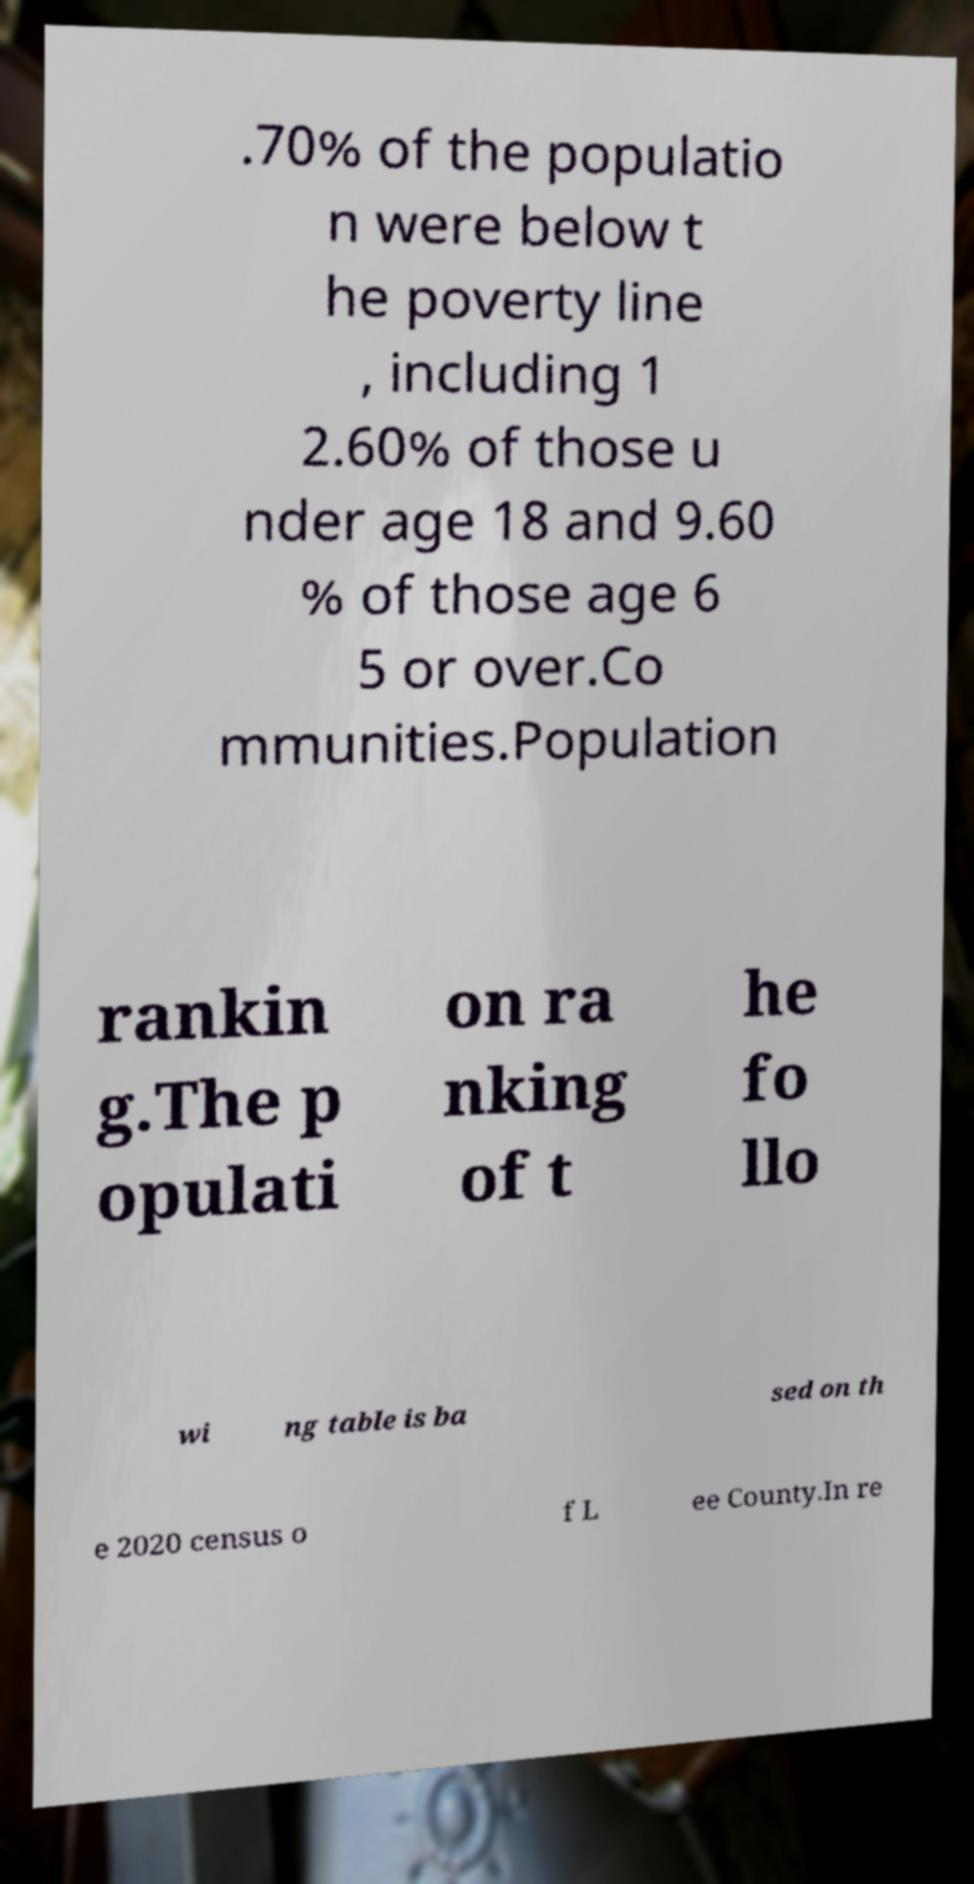Can you read and provide the text displayed in the image?This photo seems to have some interesting text. Can you extract and type it out for me? .70% of the populatio n were below t he poverty line , including 1 2.60% of those u nder age 18 and 9.60 % of those age 6 5 or over.Co mmunities.Population rankin g.The p opulati on ra nking of t he fo llo wi ng table is ba sed on th e 2020 census o f L ee County.In re 